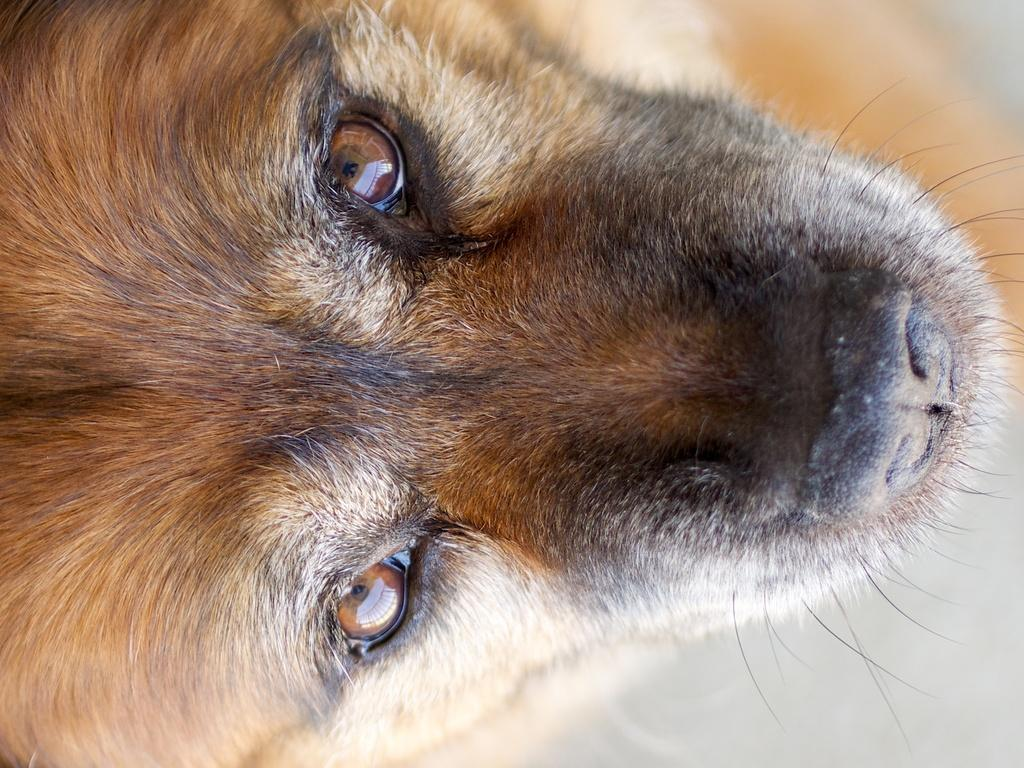What type of animal is the main subject of the image? The main subject of the image is a dog. Can you describe the dog's appearance? The dog is black and brown in color. What type of laborer is working in the background of the image? There is no laborer present in the image; it features a close-up picture of a dog. What kind of insect can be seen crawling on the dog's fur in the image? There are no insects visible in the image; it is a close-up picture of a dog with no other creatures present. 